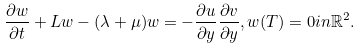Convert formula to latex. <formula><loc_0><loc_0><loc_500><loc_500>\frac { \partial w } { \partial t } + L w - ( \lambda + \mu ) w = - \frac { \partial u } { \partial y } \frac { \partial v } { \partial y } , w ( T ) = 0 i n \mathbb { R } ^ { 2 } .</formula> 